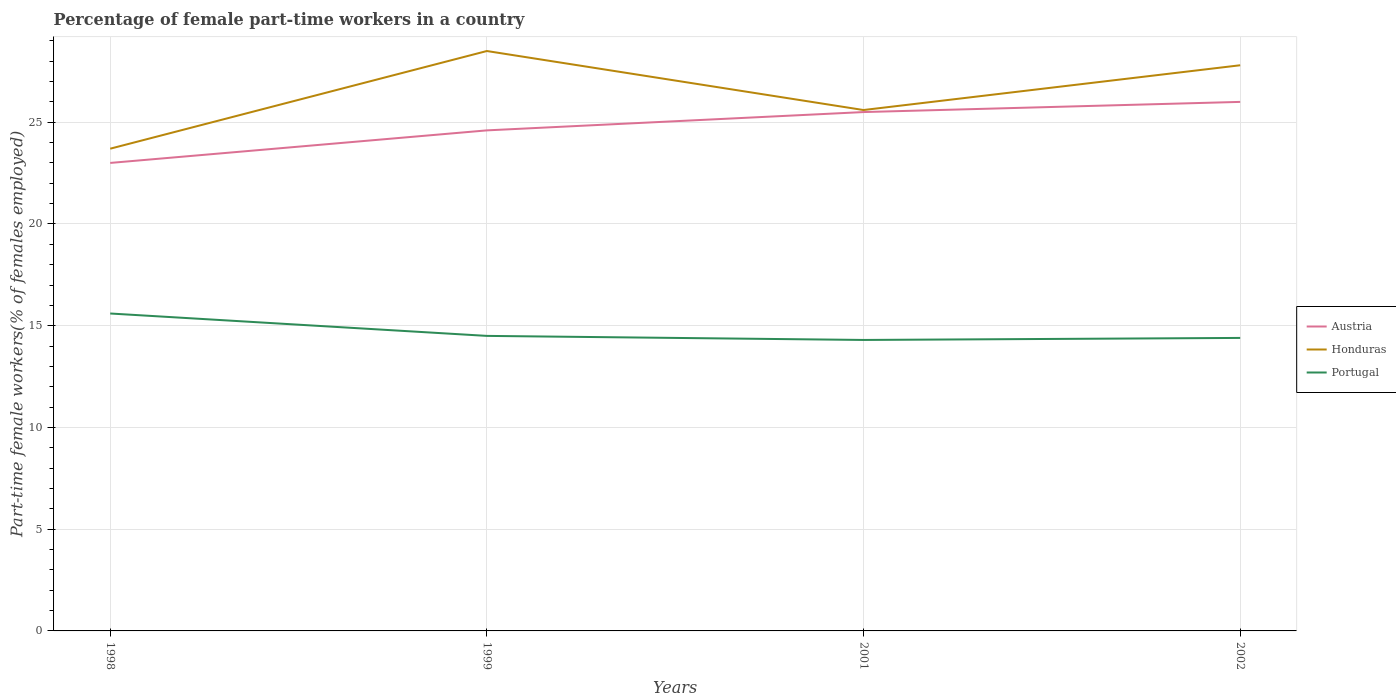How many different coloured lines are there?
Make the answer very short. 3. Does the line corresponding to Austria intersect with the line corresponding to Honduras?
Provide a succinct answer. No. Across all years, what is the maximum percentage of female part-time workers in Honduras?
Offer a terse response. 23.7. What is the total percentage of female part-time workers in Portugal in the graph?
Your answer should be compact. 1.1. What is the difference between the highest and the second highest percentage of female part-time workers in Portugal?
Give a very brief answer. 1.3. Is the percentage of female part-time workers in Austria strictly greater than the percentage of female part-time workers in Portugal over the years?
Give a very brief answer. No. What is the difference between two consecutive major ticks on the Y-axis?
Your answer should be very brief. 5. Does the graph contain grids?
Your response must be concise. Yes. Where does the legend appear in the graph?
Offer a very short reply. Center right. What is the title of the graph?
Your answer should be compact. Percentage of female part-time workers in a country. What is the label or title of the X-axis?
Give a very brief answer. Years. What is the label or title of the Y-axis?
Your response must be concise. Part-time female workers(% of females employed). What is the Part-time female workers(% of females employed) of Austria in 1998?
Your answer should be very brief. 23. What is the Part-time female workers(% of females employed) in Honduras in 1998?
Provide a short and direct response. 23.7. What is the Part-time female workers(% of females employed) of Portugal in 1998?
Keep it short and to the point. 15.6. What is the Part-time female workers(% of females employed) in Austria in 1999?
Ensure brevity in your answer.  24.6. What is the Part-time female workers(% of females employed) of Honduras in 1999?
Your answer should be very brief. 28.5. What is the Part-time female workers(% of females employed) in Honduras in 2001?
Give a very brief answer. 25.6. What is the Part-time female workers(% of females employed) of Portugal in 2001?
Your answer should be very brief. 14.3. What is the Part-time female workers(% of females employed) in Honduras in 2002?
Give a very brief answer. 27.8. What is the Part-time female workers(% of females employed) in Portugal in 2002?
Your answer should be compact. 14.4. Across all years, what is the maximum Part-time female workers(% of females employed) of Portugal?
Keep it short and to the point. 15.6. Across all years, what is the minimum Part-time female workers(% of females employed) of Honduras?
Offer a terse response. 23.7. Across all years, what is the minimum Part-time female workers(% of females employed) of Portugal?
Your response must be concise. 14.3. What is the total Part-time female workers(% of females employed) of Austria in the graph?
Offer a terse response. 99.1. What is the total Part-time female workers(% of females employed) of Honduras in the graph?
Ensure brevity in your answer.  105.6. What is the total Part-time female workers(% of females employed) of Portugal in the graph?
Ensure brevity in your answer.  58.8. What is the difference between the Part-time female workers(% of females employed) of Portugal in 1998 and that in 1999?
Your answer should be very brief. 1.1. What is the difference between the Part-time female workers(% of females employed) in Austria in 1998 and that in 2001?
Give a very brief answer. -2.5. What is the difference between the Part-time female workers(% of females employed) in Portugal in 1998 and that in 2001?
Your answer should be compact. 1.3. What is the difference between the Part-time female workers(% of females employed) in Austria in 1998 and that in 2002?
Ensure brevity in your answer.  -3. What is the difference between the Part-time female workers(% of females employed) in Honduras in 1998 and that in 2002?
Your answer should be very brief. -4.1. What is the difference between the Part-time female workers(% of females employed) in Austria in 1999 and that in 2001?
Offer a terse response. -0.9. What is the difference between the Part-time female workers(% of females employed) in Portugal in 1999 and that in 2001?
Your answer should be compact. 0.2. What is the difference between the Part-time female workers(% of females employed) of Austria in 1999 and that in 2002?
Keep it short and to the point. -1.4. What is the difference between the Part-time female workers(% of females employed) of Honduras in 1999 and that in 2002?
Your answer should be compact. 0.7. What is the difference between the Part-time female workers(% of females employed) in Portugal in 1999 and that in 2002?
Provide a succinct answer. 0.1. What is the difference between the Part-time female workers(% of females employed) in Austria in 2001 and that in 2002?
Offer a very short reply. -0.5. What is the difference between the Part-time female workers(% of females employed) in Portugal in 2001 and that in 2002?
Offer a terse response. -0.1. What is the difference between the Part-time female workers(% of females employed) of Austria in 1998 and the Part-time female workers(% of females employed) of Honduras in 1999?
Offer a very short reply. -5.5. What is the difference between the Part-time female workers(% of females employed) of Austria in 1998 and the Part-time female workers(% of females employed) of Honduras in 2001?
Your response must be concise. -2.6. What is the difference between the Part-time female workers(% of females employed) of Honduras in 1998 and the Part-time female workers(% of females employed) of Portugal in 2001?
Your answer should be compact. 9.4. What is the difference between the Part-time female workers(% of females employed) of Austria in 1998 and the Part-time female workers(% of females employed) of Portugal in 2002?
Give a very brief answer. 8.6. What is the difference between the Part-time female workers(% of females employed) in Honduras in 1999 and the Part-time female workers(% of females employed) in Portugal in 2001?
Your answer should be very brief. 14.2. What is the difference between the Part-time female workers(% of females employed) of Austria in 1999 and the Part-time female workers(% of females employed) of Honduras in 2002?
Your response must be concise. -3.2. What is the difference between the Part-time female workers(% of females employed) of Honduras in 1999 and the Part-time female workers(% of females employed) of Portugal in 2002?
Your answer should be very brief. 14.1. What is the difference between the Part-time female workers(% of females employed) in Austria in 2001 and the Part-time female workers(% of females employed) in Honduras in 2002?
Provide a short and direct response. -2.3. What is the average Part-time female workers(% of females employed) of Austria per year?
Provide a succinct answer. 24.77. What is the average Part-time female workers(% of females employed) in Honduras per year?
Keep it short and to the point. 26.4. In the year 1998, what is the difference between the Part-time female workers(% of females employed) in Austria and Part-time female workers(% of females employed) in Honduras?
Keep it short and to the point. -0.7. In the year 1998, what is the difference between the Part-time female workers(% of females employed) of Austria and Part-time female workers(% of females employed) of Portugal?
Offer a terse response. 7.4. In the year 1999, what is the difference between the Part-time female workers(% of females employed) in Austria and Part-time female workers(% of females employed) in Honduras?
Offer a terse response. -3.9. In the year 1999, what is the difference between the Part-time female workers(% of females employed) of Honduras and Part-time female workers(% of females employed) of Portugal?
Offer a terse response. 14. In the year 2001, what is the difference between the Part-time female workers(% of females employed) of Austria and Part-time female workers(% of females employed) of Portugal?
Give a very brief answer. 11.2. In the year 2002, what is the difference between the Part-time female workers(% of females employed) in Austria and Part-time female workers(% of females employed) in Honduras?
Ensure brevity in your answer.  -1.8. In the year 2002, what is the difference between the Part-time female workers(% of females employed) of Austria and Part-time female workers(% of females employed) of Portugal?
Your response must be concise. 11.6. What is the ratio of the Part-time female workers(% of females employed) in Austria in 1998 to that in 1999?
Keep it short and to the point. 0.94. What is the ratio of the Part-time female workers(% of females employed) of Honduras in 1998 to that in 1999?
Make the answer very short. 0.83. What is the ratio of the Part-time female workers(% of females employed) in Portugal in 1998 to that in 1999?
Give a very brief answer. 1.08. What is the ratio of the Part-time female workers(% of females employed) in Austria in 1998 to that in 2001?
Your answer should be compact. 0.9. What is the ratio of the Part-time female workers(% of females employed) in Honduras in 1998 to that in 2001?
Your answer should be very brief. 0.93. What is the ratio of the Part-time female workers(% of females employed) in Portugal in 1998 to that in 2001?
Offer a very short reply. 1.09. What is the ratio of the Part-time female workers(% of females employed) of Austria in 1998 to that in 2002?
Offer a very short reply. 0.88. What is the ratio of the Part-time female workers(% of females employed) of Honduras in 1998 to that in 2002?
Keep it short and to the point. 0.85. What is the ratio of the Part-time female workers(% of females employed) in Portugal in 1998 to that in 2002?
Keep it short and to the point. 1.08. What is the ratio of the Part-time female workers(% of females employed) of Austria in 1999 to that in 2001?
Offer a terse response. 0.96. What is the ratio of the Part-time female workers(% of females employed) of Honduras in 1999 to that in 2001?
Make the answer very short. 1.11. What is the ratio of the Part-time female workers(% of females employed) in Portugal in 1999 to that in 2001?
Provide a short and direct response. 1.01. What is the ratio of the Part-time female workers(% of females employed) in Austria in 1999 to that in 2002?
Offer a terse response. 0.95. What is the ratio of the Part-time female workers(% of females employed) in Honduras in 1999 to that in 2002?
Give a very brief answer. 1.03. What is the ratio of the Part-time female workers(% of females employed) in Austria in 2001 to that in 2002?
Ensure brevity in your answer.  0.98. What is the ratio of the Part-time female workers(% of females employed) in Honduras in 2001 to that in 2002?
Make the answer very short. 0.92. What is the ratio of the Part-time female workers(% of females employed) in Portugal in 2001 to that in 2002?
Offer a terse response. 0.99. What is the difference between the highest and the lowest Part-time female workers(% of females employed) in Austria?
Your answer should be very brief. 3. What is the difference between the highest and the lowest Part-time female workers(% of females employed) in Portugal?
Offer a very short reply. 1.3. 